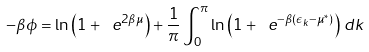<formula> <loc_0><loc_0><loc_500><loc_500>- \beta \phi = \ln \left ( 1 + \ e ^ { 2 \beta \mu } \right ) + \frac { 1 } { \pi } \int _ { 0 } ^ { \pi } \ln \left ( 1 + \ e ^ { - \beta ( \epsilon _ { k } - \mu ^ { * } ) } \right ) \, d k</formula> 